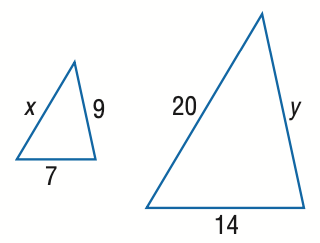Question: Find x.
Choices:
A. 5
B. 10
C. 15
D. 25
Answer with the letter. Answer: B 